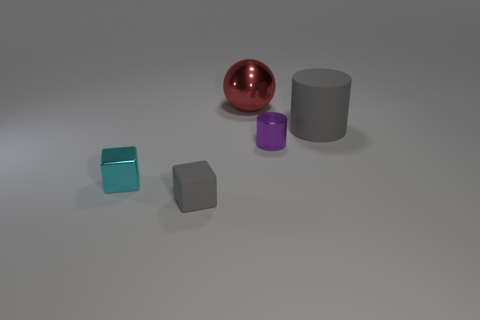Can you describe the color composition of the objects in the image? Certainly, the image displays a collection of objects with varying colors: there is a teal-colored cube, a matte gray cube, a shiny red sphere, and both a large and a small cylinder which are gray and purple, respectively. 